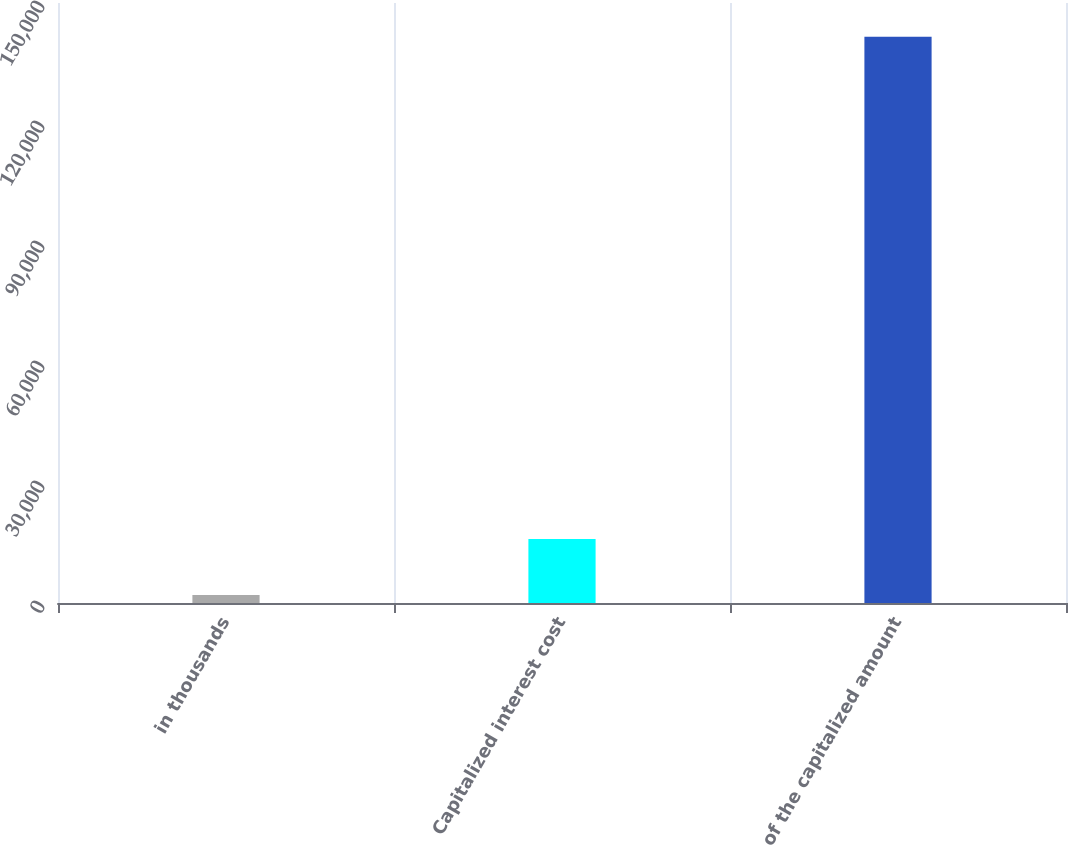Convert chart. <chart><loc_0><loc_0><loc_500><loc_500><bar_chart><fcel>in thousands<fcel>Capitalized interest cost<fcel>of the capitalized amount<nl><fcel>2016<fcel>15968.8<fcel>141544<nl></chart> 